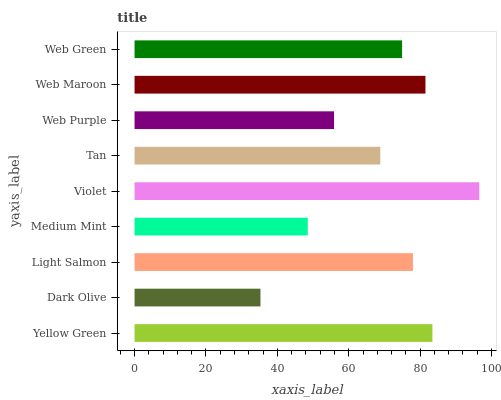Is Dark Olive the minimum?
Answer yes or no. Yes. Is Violet the maximum?
Answer yes or no. Yes. Is Light Salmon the minimum?
Answer yes or no. No. Is Light Salmon the maximum?
Answer yes or no. No. Is Light Salmon greater than Dark Olive?
Answer yes or no. Yes. Is Dark Olive less than Light Salmon?
Answer yes or no. Yes. Is Dark Olive greater than Light Salmon?
Answer yes or no. No. Is Light Salmon less than Dark Olive?
Answer yes or no. No. Is Web Green the high median?
Answer yes or no. Yes. Is Web Green the low median?
Answer yes or no. Yes. Is Medium Mint the high median?
Answer yes or no. No. Is Tan the low median?
Answer yes or no. No. 